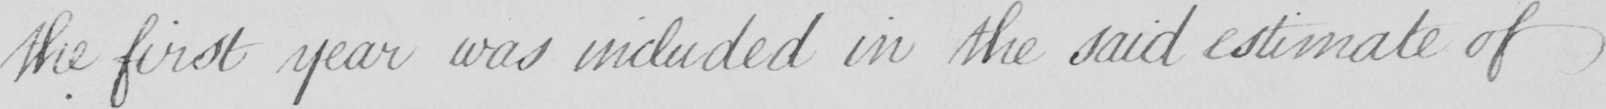Please provide the text content of this handwritten line. the first year was included in the said estimate of 